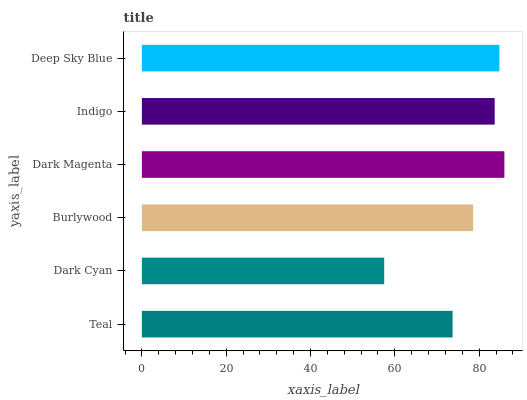Is Dark Cyan the minimum?
Answer yes or no. Yes. Is Dark Magenta the maximum?
Answer yes or no. Yes. Is Burlywood the minimum?
Answer yes or no. No. Is Burlywood the maximum?
Answer yes or no. No. Is Burlywood greater than Dark Cyan?
Answer yes or no. Yes. Is Dark Cyan less than Burlywood?
Answer yes or no. Yes. Is Dark Cyan greater than Burlywood?
Answer yes or no. No. Is Burlywood less than Dark Cyan?
Answer yes or no. No. Is Indigo the high median?
Answer yes or no. Yes. Is Burlywood the low median?
Answer yes or no. Yes. Is Dark Magenta the high median?
Answer yes or no. No. Is Dark Magenta the low median?
Answer yes or no. No. 